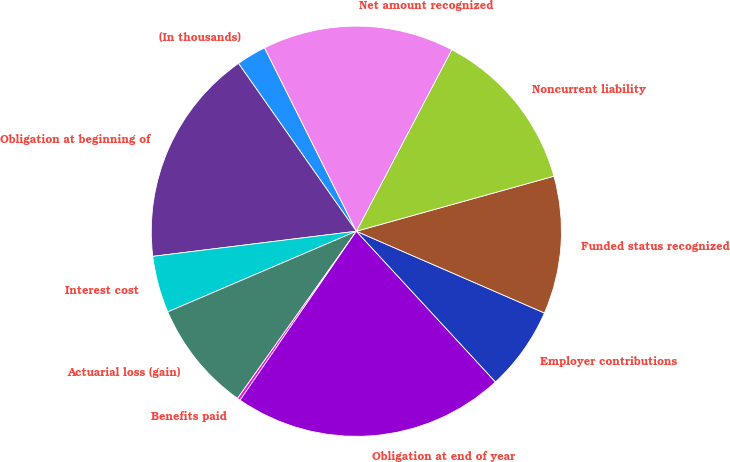Convert chart to OTSL. <chart><loc_0><loc_0><loc_500><loc_500><pie_chart><fcel>(In thousands)<fcel>Obligation at beginning of<fcel>Interest cost<fcel>Actuarial loss (gain)<fcel>Benefits paid<fcel>Obligation at end of year<fcel>Employer contributions<fcel>Funded status recognized<fcel>Noncurrent liability<fcel>Net amount recognized<nl><fcel>2.36%<fcel>17.21%<fcel>4.48%<fcel>8.73%<fcel>0.24%<fcel>21.46%<fcel>6.61%<fcel>10.85%<fcel>12.97%<fcel>15.09%<nl></chart> 